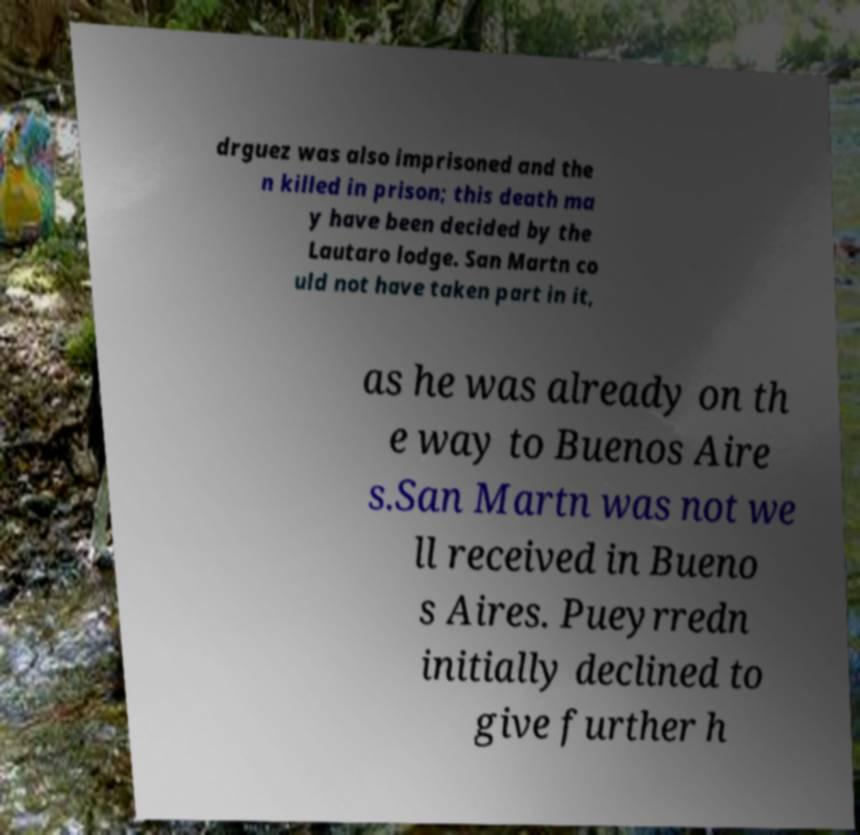For documentation purposes, I need the text within this image transcribed. Could you provide that? drguez was also imprisoned and the n killed in prison; this death ma y have been decided by the Lautaro lodge. San Martn co uld not have taken part in it, as he was already on th e way to Buenos Aire s.San Martn was not we ll received in Bueno s Aires. Pueyrredn initially declined to give further h 